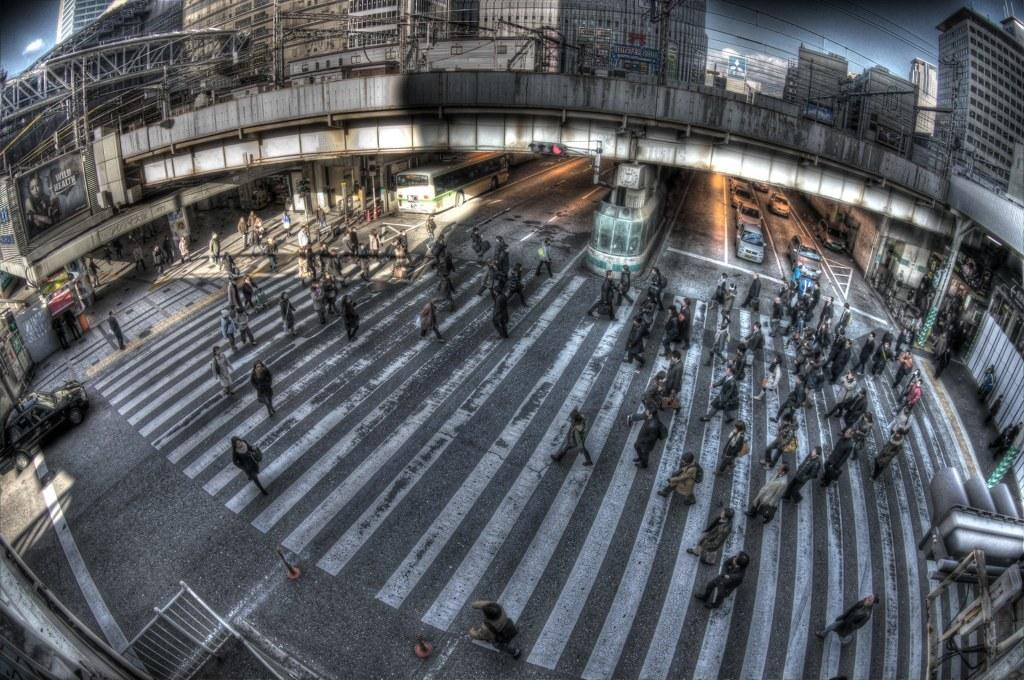Who or what can be seen in the image? There are people in the image. What else is visible on the road in the image? There are vehicles on the road in the image. What architectural feature is present over the road in the image? There is a bridge over the road in the image. What can be seen in the distance in the image? There are buildings in the background of the image. How many horses are present in the image? There are no horses visible in the image. Can you compare the size of the vehicles in the image to the size of a horse? There is no horse in the image to make a comparison with the vehicles. 